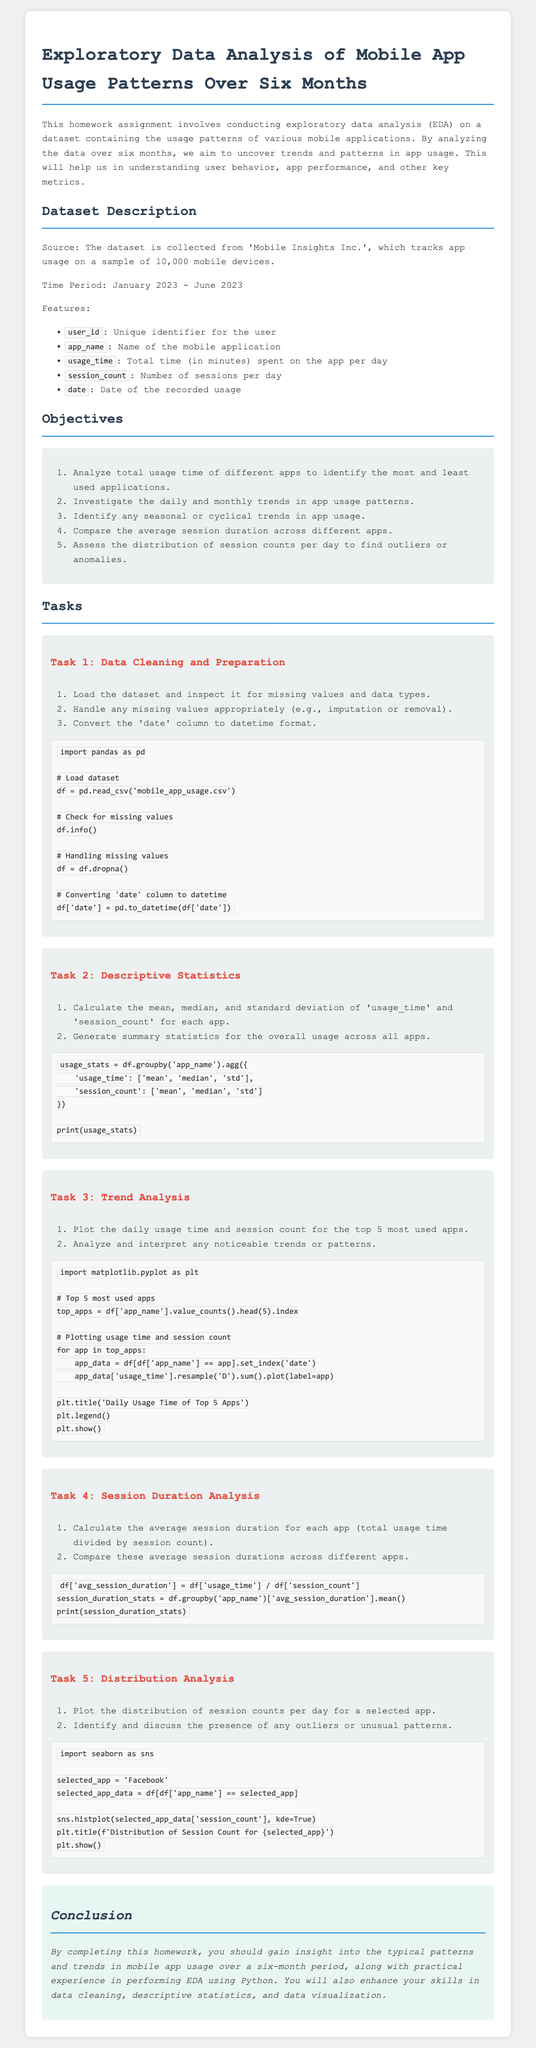What is the source of the dataset? The document states that the dataset is collected from 'Mobile Insights Inc.', which tracks app usage on a sample of 10,000 mobile devices.
Answer: Mobile Insights Inc What is the time period covered by the analysis? The document specifies that the time period for the analysis is January 2023 to June 2023.
Answer: January 2023 - June 2023 How many unique objectives are listed in the document? There are five objectives listed in the Objectives section of the document.
Answer: Five What is the first task mentioned for data cleaning and preparation? The first task in the data cleaning and preparation section is to load the dataset and inspect it for missing values and data types.
Answer: Load the dataset and inspect it for missing values and data types What is the purpose of exploratory data analysis as mentioned in the document? The purpose outlined in the document is to uncover trends and patterns in app usage, helping in understanding user behavior, app performance, and other key metrics.
Answer: Uncover trends and patterns in app usage Which library is used for plotting the distribution of session counts? The document mentions that the Seaborn library is used for this purpose.
Answer: Seaborn What statistical measures are calculated for the 'usage_time' and 'session_count'? The document states that mean, median, and standard deviation are calculated for these metrics.
Answer: Mean, median, standard deviation What is the specific app selected for the distribution analysis task? The document indicates that 'Facebook' is the selected app for this analysis.
Answer: Facebook What does the conclusion of the document emphasize? The conclusion emphasizes gaining insight into mobile app usage patterns and enhancing skills in data cleaning, descriptive statistics, and data visualization.
Answer: Insight into mobile app usage patterns 